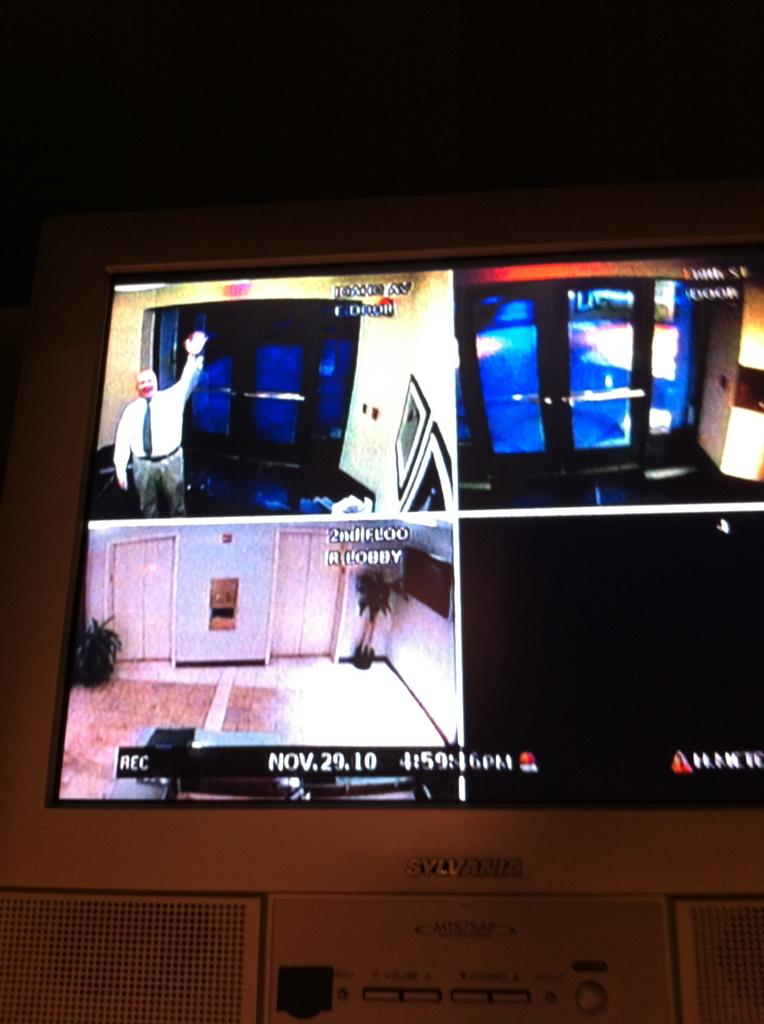<image>
Provide a brief description of the given image. the date is November 29th and there are plenty of screens 